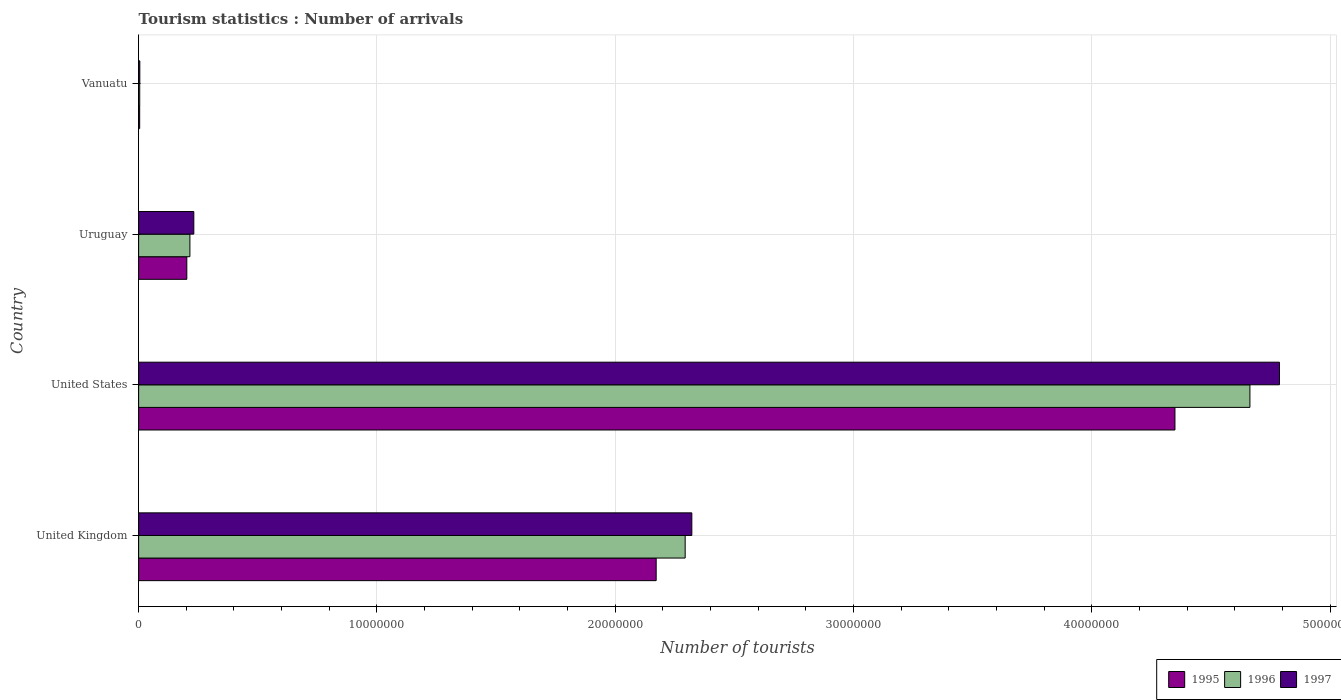How many different coloured bars are there?
Give a very brief answer. 3. Are the number of bars on each tick of the Y-axis equal?
Offer a very short reply. Yes. What is the label of the 3rd group of bars from the top?
Offer a very short reply. United States. In how many cases, is the number of bars for a given country not equal to the number of legend labels?
Provide a short and direct response. 0. What is the number of tourist arrivals in 1995 in Uruguay?
Offer a terse response. 2.02e+06. Across all countries, what is the maximum number of tourist arrivals in 1997?
Provide a succinct answer. 4.79e+07. In which country was the number of tourist arrivals in 1995 minimum?
Provide a short and direct response. Vanuatu. What is the total number of tourist arrivals in 1995 in the graph?
Provide a short and direct response. 6.73e+07. What is the difference between the number of tourist arrivals in 1995 in United Kingdom and that in United States?
Provide a short and direct response. -2.18e+07. What is the difference between the number of tourist arrivals in 1995 in United Kingdom and the number of tourist arrivals in 1996 in Uruguay?
Provide a succinct answer. 1.96e+07. What is the average number of tourist arrivals in 1995 per country?
Offer a terse response. 1.68e+07. What is the difference between the number of tourist arrivals in 1995 and number of tourist arrivals in 1996 in United Kingdom?
Ensure brevity in your answer.  -1.22e+06. In how many countries, is the number of tourist arrivals in 1997 greater than 48000000 ?
Your answer should be compact. 0. What is the ratio of the number of tourist arrivals in 1996 in Uruguay to that in Vanuatu?
Make the answer very short. 46.78. What is the difference between the highest and the second highest number of tourist arrivals in 1996?
Provide a short and direct response. 2.37e+07. What is the difference between the highest and the lowest number of tourist arrivals in 1997?
Ensure brevity in your answer.  4.78e+07. What does the 1st bar from the top in Uruguay represents?
Give a very brief answer. 1997. What does the 2nd bar from the bottom in Uruguay represents?
Ensure brevity in your answer.  1996. Are all the bars in the graph horizontal?
Make the answer very short. Yes. Does the graph contain grids?
Make the answer very short. Yes. Where does the legend appear in the graph?
Provide a short and direct response. Bottom right. How many legend labels are there?
Offer a very short reply. 3. How are the legend labels stacked?
Provide a short and direct response. Horizontal. What is the title of the graph?
Offer a terse response. Tourism statistics : Number of arrivals. What is the label or title of the X-axis?
Provide a succinct answer. Number of tourists. What is the Number of tourists of 1995 in United Kingdom?
Offer a terse response. 2.17e+07. What is the Number of tourists in 1996 in United Kingdom?
Your answer should be very brief. 2.29e+07. What is the Number of tourists in 1997 in United Kingdom?
Offer a terse response. 2.32e+07. What is the Number of tourists in 1995 in United States?
Keep it short and to the point. 4.35e+07. What is the Number of tourists of 1996 in United States?
Give a very brief answer. 4.66e+07. What is the Number of tourists in 1997 in United States?
Your answer should be very brief. 4.79e+07. What is the Number of tourists of 1995 in Uruguay?
Provide a succinct answer. 2.02e+06. What is the Number of tourists in 1996 in Uruguay?
Keep it short and to the point. 2.15e+06. What is the Number of tourists of 1997 in Uruguay?
Your response must be concise. 2.32e+06. What is the Number of tourists of 1995 in Vanuatu?
Your answer should be very brief. 4.40e+04. What is the Number of tourists in 1996 in Vanuatu?
Keep it short and to the point. 4.60e+04. What is the Number of tourists of 1997 in Vanuatu?
Provide a short and direct response. 5.00e+04. Across all countries, what is the maximum Number of tourists of 1995?
Provide a succinct answer. 4.35e+07. Across all countries, what is the maximum Number of tourists of 1996?
Your answer should be compact. 4.66e+07. Across all countries, what is the maximum Number of tourists in 1997?
Offer a very short reply. 4.79e+07. Across all countries, what is the minimum Number of tourists of 1995?
Your answer should be very brief. 4.40e+04. Across all countries, what is the minimum Number of tourists in 1996?
Keep it short and to the point. 4.60e+04. Across all countries, what is the minimum Number of tourists of 1997?
Ensure brevity in your answer.  5.00e+04. What is the total Number of tourists in 1995 in the graph?
Ensure brevity in your answer.  6.73e+07. What is the total Number of tourists in 1996 in the graph?
Provide a succinct answer. 7.18e+07. What is the total Number of tourists in 1997 in the graph?
Provide a short and direct response. 7.35e+07. What is the difference between the Number of tourists in 1995 in United Kingdom and that in United States?
Ensure brevity in your answer.  -2.18e+07. What is the difference between the Number of tourists of 1996 in United Kingdom and that in United States?
Your answer should be very brief. -2.37e+07. What is the difference between the Number of tourists in 1997 in United Kingdom and that in United States?
Offer a very short reply. -2.47e+07. What is the difference between the Number of tourists of 1995 in United Kingdom and that in Uruguay?
Give a very brief answer. 1.97e+07. What is the difference between the Number of tourists of 1996 in United Kingdom and that in Uruguay?
Offer a very short reply. 2.08e+07. What is the difference between the Number of tourists in 1997 in United Kingdom and that in Uruguay?
Your answer should be very brief. 2.09e+07. What is the difference between the Number of tourists in 1995 in United Kingdom and that in Vanuatu?
Your answer should be very brief. 2.17e+07. What is the difference between the Number of tourists in 1996 in United Kingdom and that in Vanuatu?
Provide a succinct answer. 2.29e+07. What is the difference between the Number of tourists of 1997 in United Kingdom and that in Vanuatu?
Your answer should be compact. 2.32e+07. What is the difference between the Number of tourists in 1995 in United States and that in Uruguay?
Your response must be concise. 4.15e+07. What is the difference between the Number of tourists in 1996 in United States and that in Uruguay?
Offer a very short reply. 4.45e+07. What is the difference between the Number of tourists of 1997 in United States and that in Uruguay?
Your answer should be very brief. 4.56e+07. What is the difference between the Number of tourists in 1995 in United States and that in Vanuatu?
Provide a succinct answer. 4.34e+07. What is the difference between the Number of tourists of 1996 in United States and that in Vanuatu?
Ensure brevity in your answer.  4.66e+07. What is the difference between the Number of tourists in 1997 in United States and that in Vanuatu?
Your response must be concise. 4.78e+07. What is the difference between the Number of tourists of 1995 in Uruguay and that in Vanuatu?
Make the answer very short. 1.98e+06. What is the difference between the Number of tourists in 1996 in Uruguay and that in Vanuatu?
Provide a short and direct response. 2.11e+06. What is the difference between the Number of tourists of 1997 in Uruguay and that in Vanuatu?
Your answer should be compact. 2.27e+06. What is the difference between the Number of tourists of 1995 in United Kingdom and the Number of tourists of 1996 in United States?
Your response must be concise. -2.49e+07. What is the difference between the Number of tourists of 1995 in United Kingdom and the Number of tourists of 1997 in United States?
Your response must be concise. -2.62e+07. What is the difference between the Number of tourists in 1996 in United Kingdom and the Number of tourists in 1997 in United States?
Provide a succinct answer. -2.49e+07. What is the difference between the Number of tourists in 1995 in United Kingdom and the Number of tourists in 1996 in Uruguay?
Offer a very short reply. 1.96e+07. What is the difference between the Number of tourists in 1995 in United Kingdom and the Number of tourists in 1997 in Uruguay?
Your answer should be very brief. 1.94e+07. What is the difference between the Number of tourists in 1996 in United Kingdom and the Number of tourists in 1997 in Uruguay?
Offer a very short reply. 2.06e+07. What is the difference between the Number of tourists of 1995 in United Kingdom and the Number of tourists of 1996 in Vanuatu?
Your answer should be very brief. 2.17e+07. What is the difference between the Number of tourists of 1995 in United Kingdom and the Number of tourists of 1997 in Vanuatu?
Ensure brevity in your answer.  2.17e+07. What is the difference between the Number of tourists in 1996 in United Kingdom and the Number of tourists in 1997 in Vanuatu?
Your answer should be very brief. 2.29e+07. What is the difference between the Number of tourists of 1995 in United States and the Number of tourists of 1996 in Uruguay?
Your response must be concise. 4.13e+07. What is the difference between the Number of tourists in 1995 in United States and the Number of tourists in 1997 in Uruguay?
Offer a very short reply. 4.12e+07. What is the difference between the Number of tourists in 1996 in United States and the Number of tourists in 1997 in Uruguay?
Offer a terse response. 4.43e+07. What is the difference between the Number of tourists in 1995 in United States and the Number of tourists in 1996 in Vanuatu?
Provide a short and direct response. 4.34e+07. What is the difference between the Number of tourists of 1995 in United States and the Number of tourists of 1997 in Vanuatu?
Give a very brief answer. 4.34e+07. What is the difference between the Number of tourists in 1996 in United States and the Number of tourists in 1997 in Vanuatu?
Your answer should be compact. 4.66e+07. What is the difference between the Number of tourists in 1995 in Uruguay and the Number of tourists in 1996 in Vanuatu?
Provide a succinct answer. 1.98e+06. What is the difference between the Number of tourists in 1995 in Uruguay and the Number of tourists in 1997 in Vanuatu?
Your response must be concise. 1.97e+06. What is the difference between the Number of tourists of 1996 in Uruguay and the Number of tourists of 1997 in Vanuatu?
Provide a short and direct response. 2.10e+06. What is the average Number of tourists in 1995 per country?
Ensure brevity in your answer.  1.68e+07. What is the average Number of tourists of 1996 per country?
Ensure brevity in your answer.  1.79e+07. What is the average Number of tourists in 1997 per country?
Give a very brief answer. 1.84e+07. What is the difference between the Number of tourists of 1995 and Number of tourists of 1996 in United Kingdom?
Provide a short and direct response. -1.22e+06. What is the difference between the Number of tourists in 1995 and Number of tourists in 1997 in United Kingdom?
Your response must be concise. -1.50e+06. What is the difference between the Number of tourists of 1996 and Number of tourists of 1997 in United Kingdom?
Your answer should be compact. -2.79e+05. What is the difference between the Number of tourists in 1995 and Number of tourists in 1996 in United States?
Ensure brevity in your answer.  -3.15e+06. What is the difference between the Number of tourists in 1995 and Number of tourists in 1997 in United States?
Offer a very short reply. -4.38e+06. What is the difference between the Number of tourists of 1996 and Number of tourists of 1997 in United States?
Offer a very short reply. -1.24e+06. What is the difference between the Number of tourists of 1995 and Number of tourists of 1997 in Uruguay?
Offer a terse response. -2.94e+05. What is the difference between the Number of tourists of 1996 and Number of tourists of 1997 in Uruguay?
Ensure brevity in your answer.  -1.64e+05. What is the difference between the Number of tourists of 1995 and Number of tourists of 1996 in Vanuatu?
Your answer should be very brief. -2000. What is the difference between the Number of tourists in 1995 and Number of tourists in 1997 in Vanuatu?
Ensure brevity in your answer.  -6000. What is the difference between the Number of tourists of 1996 and Number of tourists of 1997 in Vanuatu?
Provide a succinct answer. -4000. What is the ratio of the Number of tourists of 1995 in United Kingdom to that in United States?
Make the answer very short. 0.5. What is the ratio of the Number of tourists in 1996 in United Kingdom to that in United States?
Offer a very short reply. 0.49. What is the ratio of the Number of tourists of 1997 in United Kingdom to that in United States?
Provide a short and direct response. 0.48. What is the ratio of the Number of tourists in 1995 in United Kingdom to that in Uruguay?
Offer a very short reply. 10.74. What is the ratio of the Number of tourists in 1996 in United Kingdom to that in Uruguay?
Keep it short and to the point. 10.66. What is the ratio of the Number of tourists of 1997 in United Kingdom to that in Uruguay?
Your answer should be very brief. 10.02. What is the ratio of the Number of tourists in 1995 in United Kingdom to that in Vanuatu?
Your answer should be very brief. 493.61. What is the ratio of the Number of tourists of 1996 in United Kingdom to that in Vanuatu?
Ensure brevity in your answer.  498.61. What is the ratio of the Number of tourists in 1997 in United Kingdom to that in Vanuatu?
Your answer should be compact. 464.3. What is the ratio of the Number of tourists in 1995 in United States to that in Uruguay?
Ensure brevity in your answer.  21.51. What is the ratio of the Number of tourists of 1996 in United States to that in Uruguay?
Give a very brief answer. 21.67. What is the ratio of the Number of tourists in 1997 in United States to that in Uruguay?
Offer a very short reply. 20.67. What is the ratio of the Number of tourists in 1995 in United States to that in Vanuatu?
Offer a very short reply. 988.41. What is the ratio of the Number of tourists in 1996 in United States to that in Vanuatu?
Provide a short and direct response. 1013.83. What is the ratio of the Number of tourists of 1997 in United States to that in Vanuatu?
Your answer should be compact. 957.5. What is the ratio of the Number of tourists of 1995 in Uruguay to that in Vanuatu?
Your answer should be very brief. 45.95. What is the ratio of the Number of tourists in 1996 in Uruguay to that in Vanuatu?
Give a very brief answer. 46.78. What is the ratio of the Number of tourists in 1997 in Uruguay to that in Vanuatu?
Your response must be concise. 46.32. What is the difference between the highest and the second highest Number of tourists in 1995?
Your response must be concise. 2.18e+07. What is the difference between the highest and the second highest Number of tourists of 1996?
Keep it short and to the point. 2.37e+07. What is the difference between the highest and the second highest Number of tourists of 1997?
Provide a succinct answer. 2.47e+07. What is the difference between the highest and the lowest Number of tourists of 1995?
Make the answer very short. 4.34e+07. What is the difference between the highest and the lowest Number of tourists of 1996?
Make the answer very short. 4.66e+07. What is the difference between the highest and the lowest Number of tourists of 1997?
Make the answer very short. 4.78e+07. 